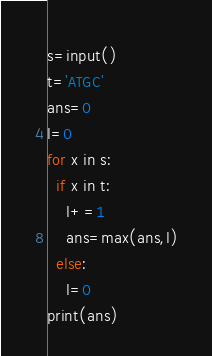<code> <loc_0><loc_0><loc_500><loc_500><_Python_>s=input()
t='ATGC'
ans=0
l=0
for x in s:
  if x in t:
    l+=1
    ans=max(ans,l)
  else:
    l=0
print(ans)</code> 